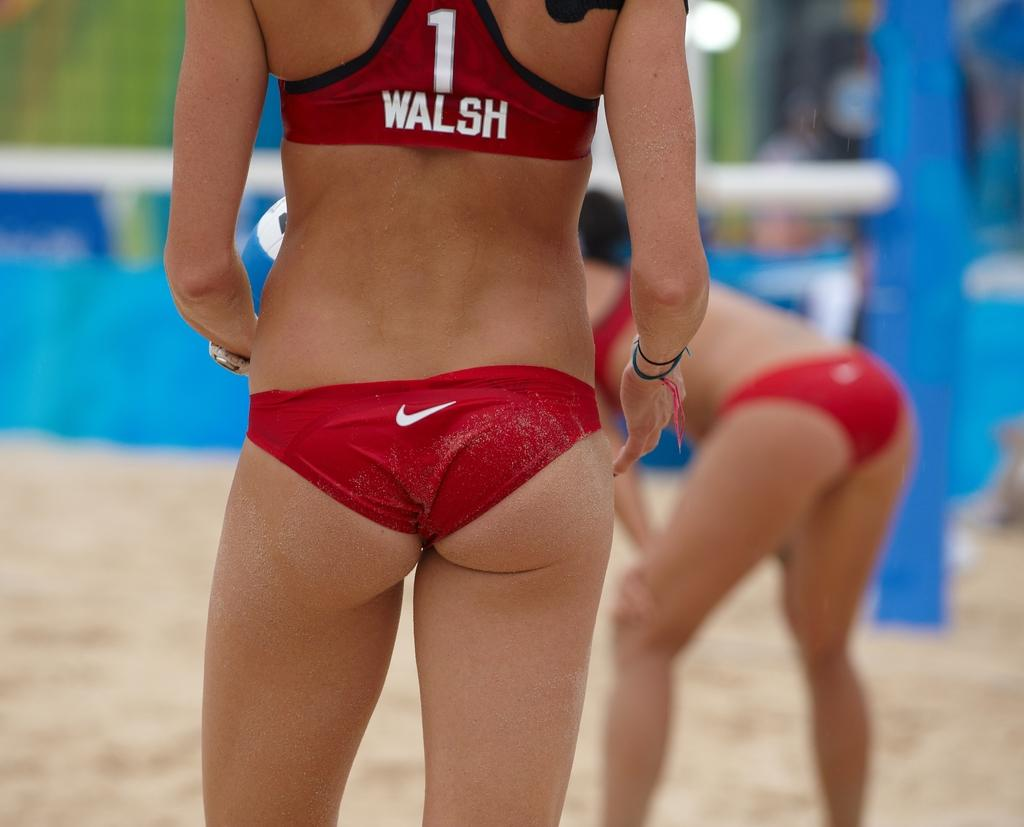<image>
Create a compact narrative representing the image presented. On the woman shirt is the word Walsh. 